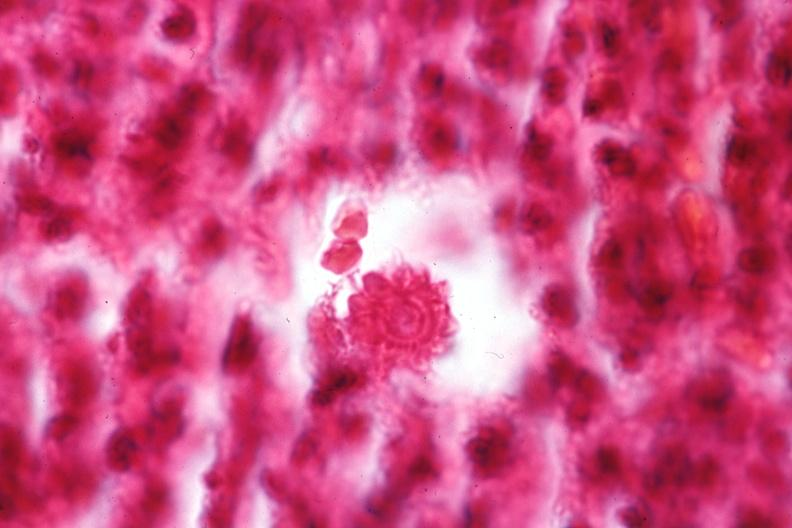does this image show oil immersion organism very well shown?
Answer the question using a single word or phrase. Yes 